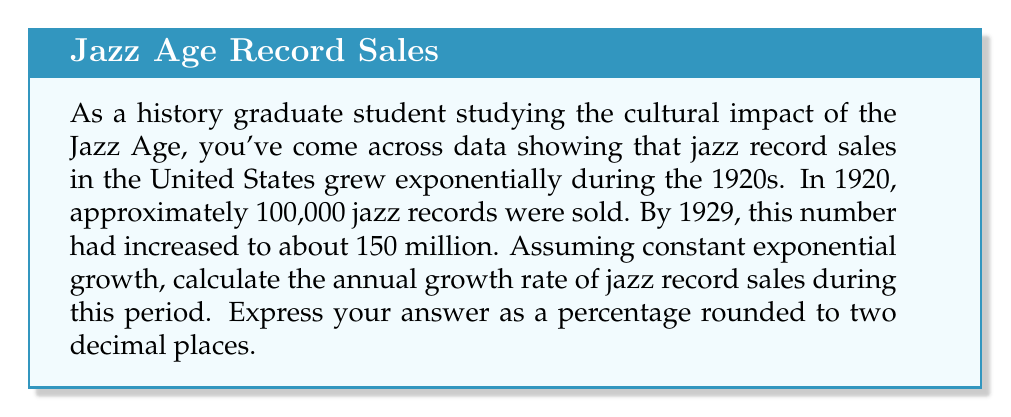What is the answer to this math problem? To solve this problem, we'll use the exponential growth formula:

$$ A = P(1 + r)^t $$

Where:
$A$ is the final amount (150 million)
$P$ is the initial amount (100,000)
$r$ is the annual growth rate (what we're solving for)
$t$ is the time period in years (1929 - 1920 = 9 years)

Let's plug in the values:

$$ 150,000,000 = 100,000(1 + r)^9 $$

To solve for $r$, we'll use logarithms:

1) First, divide both sides by 100,000:
   $$ 1500 = (1 + r)^9 $$

2) Take the natural log of both sides:
   $$ \ln(1500) = \ln((1 + r)^9) $$

3) Use the logarithm property $\ln(a^b) = b\ln(a)$:
   $$ \ln(1500) = 9\ln(1 + r) $$

4) Divide both sides by 9:
   $$ \frac{\ln(1500)}{9} = \ln(1 + r) $$

5) Take $e$ to the power of both sides:
   $$ e^{\frac{\ln(1500)}{9}} = e^{\ln(1 + r)} = 1 + r $$

6) Subtract 1 from both sides:
   $$ e^{\frac{\ln(1500)}{9}} - 1 = r $$

7) Calculate the value:
   $$ r \approx 0.8731 $$

8) Convert to a percentage:
   $$ r \approx 87.31\% $$
Answer: The annual growth rate of jazz record sales during the 1920s was approximately 87.31%. 